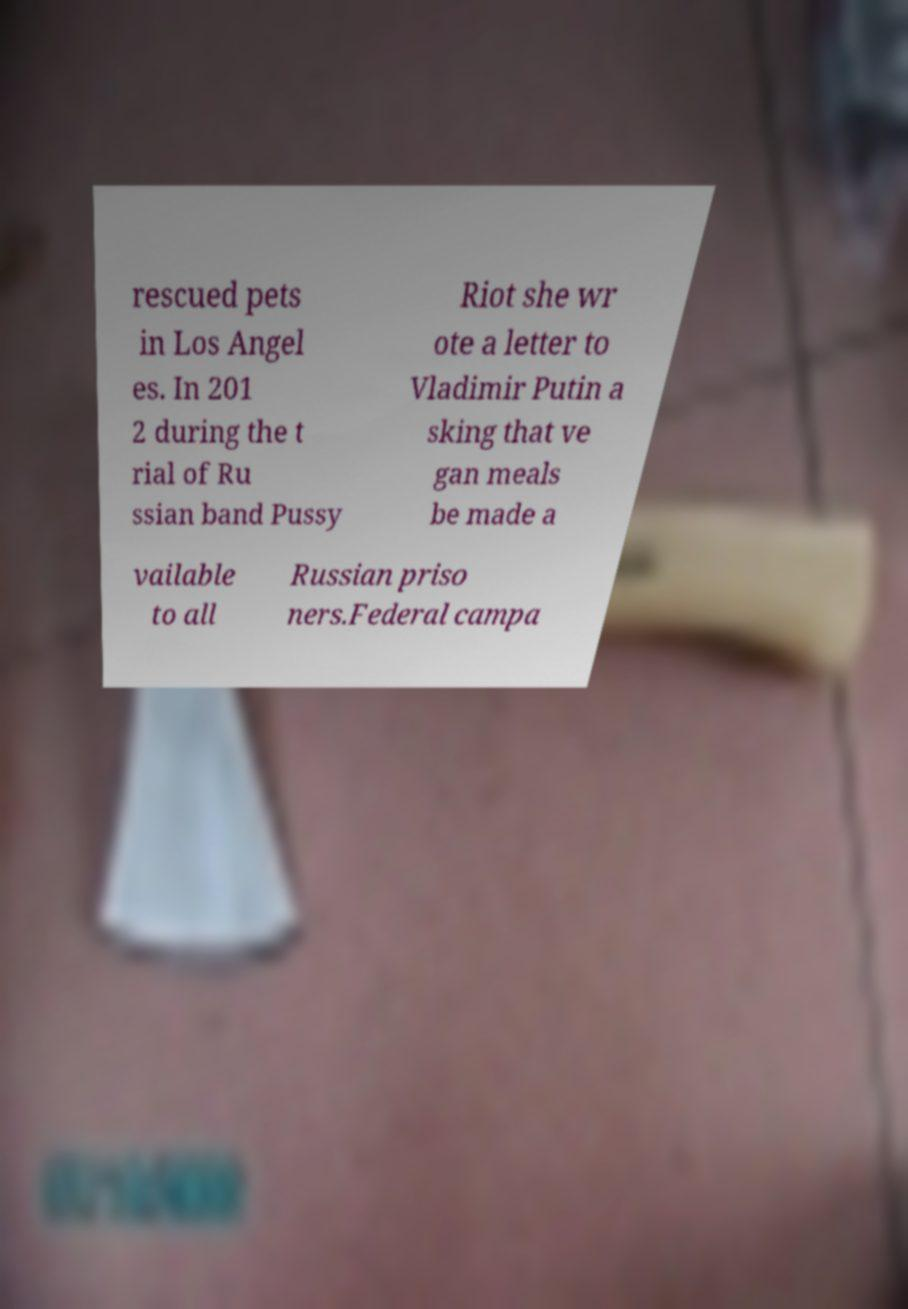Please read and relay the text visible in this image. What does it say? rescued pets in Los Angel es. In 201 2 during the t rial of Ru ssian band Pussy Riot she wr ote a letter to Vladimir Putin a sking that ve gan meals be made a vailable to all Russian priso ners.Federal campa 